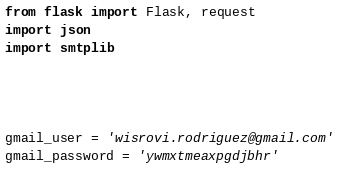<code> <loc_0><loc_0><loc_500><loc_500><_Python_>from flask import Flask, request
import json
import smtplib




gmail_user = 'wisrovi.rodriguez@gmail.com'
gmail_password = 'ywmxtmeaxpgdjbhr'</code> 